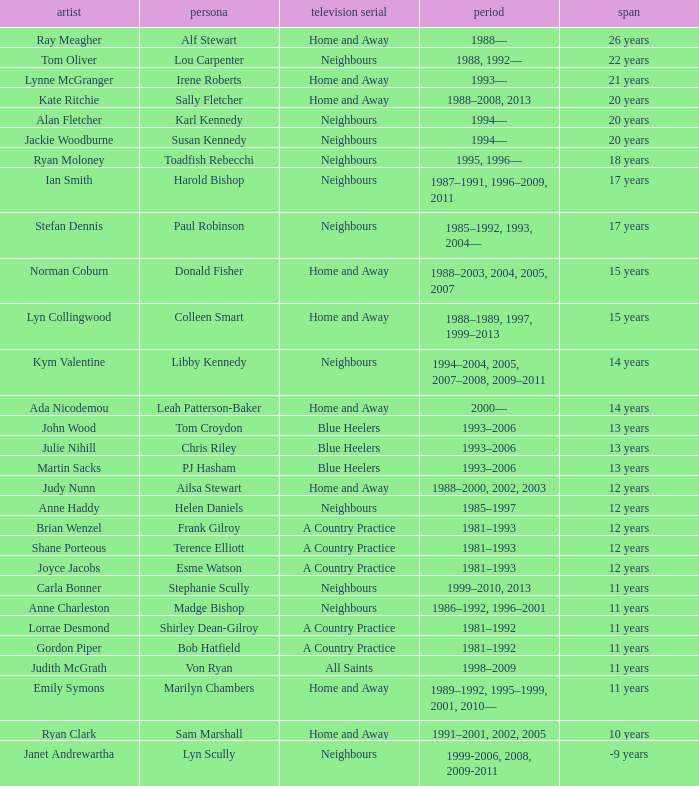Help me parse the entirety of this table. {'header': ['artist', 'persona', 'television serial', 'period', 'span'], 'rows': [['Ray Meagher', 'Alf Stewart', 'Home and Away', '1988—', '26 years'], ['Tom Oliver', 'Lou Carpenter', 'Neighbours', '1988, 1992—', '22 years'], ['Lynne McGranger', 'Irene Roberts', 'Home and Away', '1993—', '21 years'], ['Kate Ritchie', 'Sally Fletcher', 'Home and Away', '1988–2008, 2013', '20 years'], ['Alan Fletcher', 'Karl Kennedy', 'Neighbours', '1994—', '20 years'], ['Jackie Woodburne', 'Susan Kennedy', 'Neighbours', '1994—', '20 years'], ['Ryan Moloney', 'Toadfish Rebecchi', 'Neighbours', '1995, 1996—', '18 years'], ['Ian Smith', 'Harold Bishop', 'Neighbours', '1987–1991, 1996–2009, 2011', '17 years'], ['Stefan Dennis', 'Paul Robinson', 'Neighbours', '1985–1992, 1993, 2004—', '17 years'], ['Norman Coburn', 'Donald Fisher', 'Home and Away', '1988–2003, 2004, 2005, 2007', '15 years'], ['Lyn Collingwood', 'Colleen Smart', 'Home and Away', '1988–1989, 1997, 1999–2013', '15 years'], ['Kym Valentine', 'Libby Kennedy', 'Neighbours', '1994–2004, 2005, 2007–2008, 2009–2011', '14 years'], ['Ada Nicodemou', 'Leah Patterson-Baker', 'Home and Away', '2000—', '14 years'], ['John Wood', 'Tom Croydon', 'Blue Heelers', '1993–2006', '13 years'], ['Julie Nihill', 'Chris Riley', 'Blue Heelers', '1993–2006', '13 years'], ['Martin Sacks', 'PJ Hasham', 'Blue Heelers', '1993–2006', '13 years'], ['Judy Nunn', 'Ailsa Stewart', 'Home and Away', '1988–2000, 2002, 2003', '12 years'], ['Anne Haddy', 'Helen Daniels', 'Neighbours', '1985–1997', '12 years'], ['Brian Wenzel', 'Frank Gilroy', 'A Country Practice', '1981–1993', '12 years'], ['Shane Porteous', 'Terence Elliott', 'A Country Practice', '1981–1993', '12 years'], ['Joyce Jacobs', 'Esme Watson', 'A Country Practice', '1981–1993', '12 years'], ['Carla Bonner', 'Stephanie Scully', 'Neighbours', '1999–2010, 2013', '11 years'], ['Anne Charleston', 'Madge Bishop', 'Neighbours', '1986–1992, 1996–2001', '11 years'], ['Lorrae Desmond', 'Shirley Dean-Gilroy', 'A Country Practice', '1981–1992', '11 years'], ['Gordon Piper', 'Bob Hatfield', 'A Country Practice', '1981–1992', '11 years'], ['Judith McGrath', 'Von Ryan', 'All Saints', '1998–2009', '11 years'], ['Emily Symons', 'Marilyn Chambers', 'Home and Away', '1989–1992, 1995–1999, 2001, 2010—', '11 years'], ['Ryan Clark', 'Sam Marshall', 'Home and Away', '1991–2001, 2002, 2005', '10 years'], ['Janet Andrewartha', 'Lyn Scully', 'Neighbours', '1999-2006, 2008, 2009-2011', '-9 years']]} Which actor played Harold Bishop for 17 years? Ian Smith. 